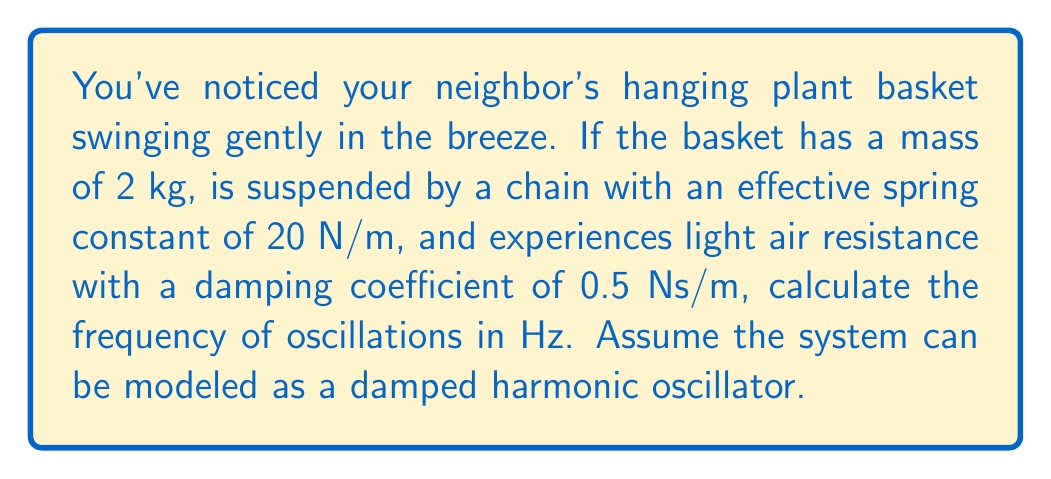Could you help me with this problem? To solve this problem, we'll use the equation for the frequency of a damped harmonic oscillator:

$$f = \frac{1}{2\pi} \sqrt{\frac{k}{m} - \frac{c^2}{4m^2}}$$

Where:
$f$ = frequency in Hz
$k$ = spring constant in N/m
$m$ = mass in kg
$c$ = damping coefficient in Ns/m

Given:
$m = 2$ kg
$k = 20$ N/m
$c = 0.5$ Ns/m

Let's substitute these values into the equation:

$$f = \frac{1}{2\pi} \sqrt{\frac{20}{2} - \frac{0.5^2}{4(2^2)}}$$

Simplifying:

$$f = \frac{1}{2\pi} \sqrt{10 - \frac{0.25}{16}}$$

$$f = \frac{1}{2\pi} \sqrt{10 - 0.015625}$$

$$f = \frac{1}{2\pi} \sqrt{9.984375}$$

$$f = \frac{1}{2\pi} (3.1598)$$

$$f = 0.5028 \text{ Hz}$$

Rounding to two decimal places:

$$f \approx 0.50 \text{ Hz}$$
Answer: The frequency of oscillations for the hanging plant basket is approximately 0.50 Hz. 